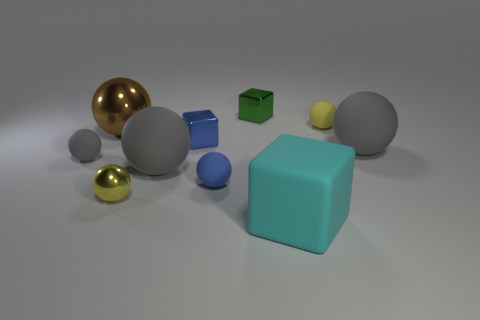Subtract all yellow cylinders. How many gray balls are left? 3 Subtract all metal cubes. How many cubes are left? 1 Subtract all yellow balls. How many balls are left? 5 Subtract 4 balls. How many balls are left? 3 Subtract all green spheres. Subtract all blue cylinders. How many spheres are left? 7 Subtract 0 green spheres. How many objects are left? 10 Subtract all balls. How many objects are left? 3 Subtract all purple balls. Subtract all yellow things. How many objects are left? 8 Add 8 yellow rubber balls. How many yellow rubber balls are left? 9 Add 6 large gray cylinders. How many large gray cylinders exist? 6 